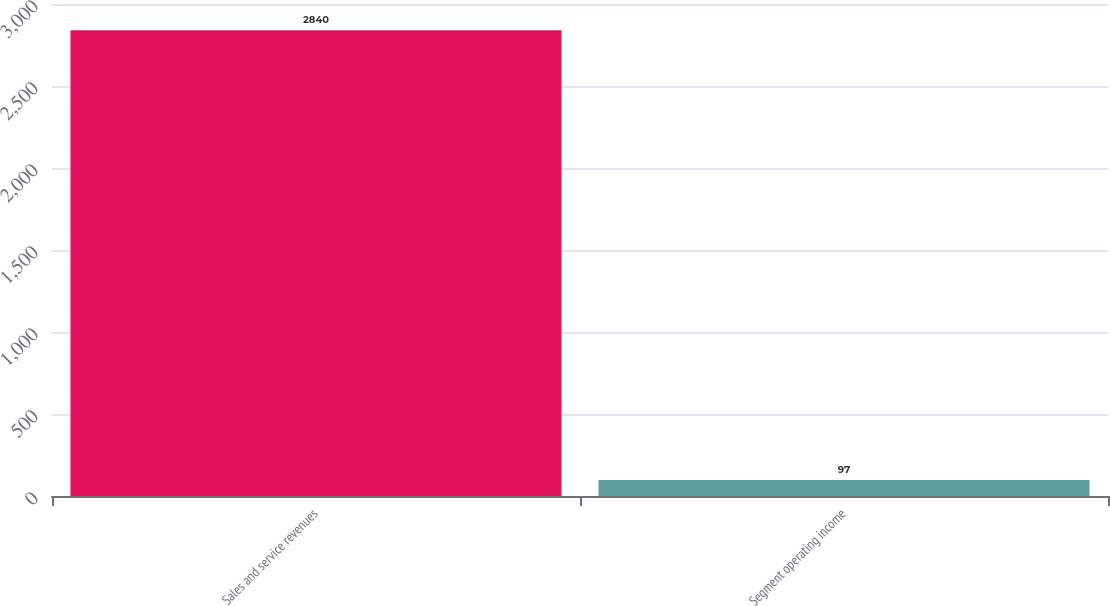Convert chart to OTSL. <chart><loc_0><loc_0><loc_500><loc_500><bar_chart><fcel>Sales and service revenues<fcel>Segment operating income<nl><fcel>2840<fcel>97<nl></chart> 